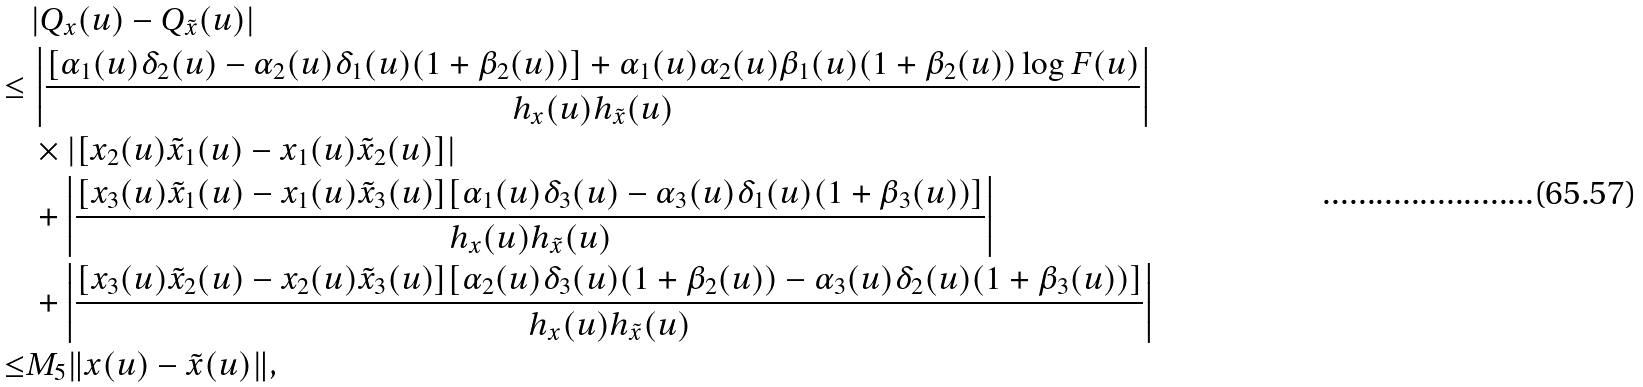<formula> <loc_0><loc_0><loc_500><loc_500>& \, | Q _ { x } ( u ) - Q _ { \tilde { x } } ( u ) | \\ \leq & \, \left | \frac { [ \alpha _ { 1 } ( u ) \delta _ { 2 } ( u ) - \alpha _ { 2 } ( u ) \delta _ { 1 } ( u ) ( 1 + \beta _ { 2 } ( u ) ) ] + \alpha _ { 1 } ( u ) \alpha _ { 2 } ( u ) \beta _ { 1 } ( u ) ( 1 + \beta _ { 2 } ( u ) ) \log F ( u ) } { h _ { x } ( u ) h _ { \tilde { x } } ( u ) } \right | \\ & \, \times | [ x _ { 2 } ( u ) \tilde { x } _ { 1 } ( u ) - x _ { 1 } ( u ) \tilde { x } _ { 2 } ( u ) ] | \\ & \, + \left | \frac { [ x _ { 3 } ( u ) \tilde { x } _ { 1 } ( u ) - x _ { 1 } ( u ) \tilde { x } _ { 3 } ( u ) ] [ \alpha _ { 1 } ( u ) \delta _ { 3 } ( u ) - \alpha _ { 3 } ( u ) \delta _ { 1 } ( u ) ( 1 + \beta _ { 3 } ( u ) ) ] } { h _ { x } ( u ) h _ { \tilde { x } } ( u ) } \right | \\ & \, + \left | \frac { [ x _ { 3 } ( u ) \tilde { x } _ { 2 } ( u ) - x _ { 2 } ( u ) \tilde { x } _ { 3 } ( u ) ] [ \alpha _ { 2 } ( u ) \delta _ { 3 } ( u ) ( 1 + \beta _ { 2 } ( u ) ) - \alpha _ { 3 } ( u ) \delta _ { 2 } ( u ) ( 1 + \beta _ { 3 } ( u ) ) ] } { h _ { x } ( u ) h _ { \tilde { x } } ( u ) } \right | \\ \leq & M _ { 5 } \| x ( u ) - \tilde { x } ( u ) \| ,</formula> 